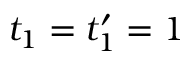<formula> <loc_0><loc_0><loc_500><loc_500>t _ { 1 } = t _ { 1 } ^ { \prime } = 1</formula> 